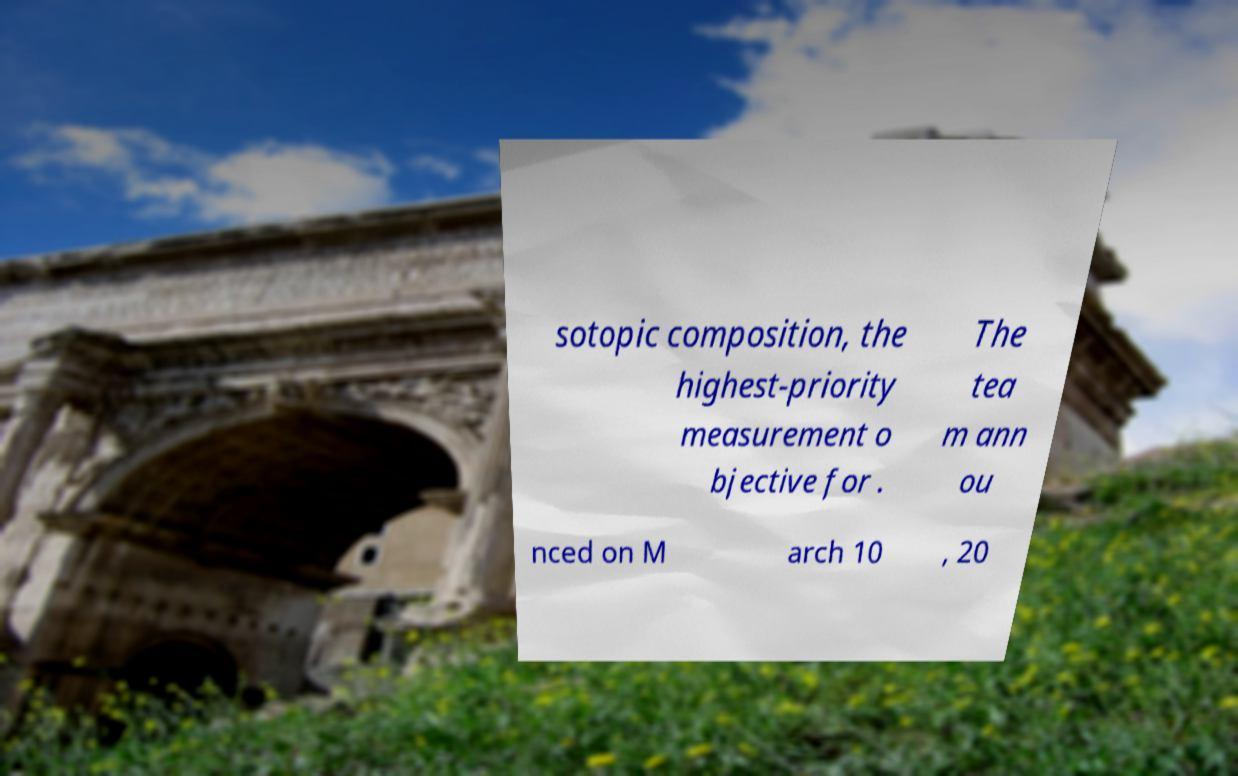Can you read and provide the text displayed in the image?This photo seems to have some interesting text. Can you extract and type it out for me? sotopic composition, the highest-priority measurement o bjective for . The tea m ann ou nced on M arch 10 , 20 